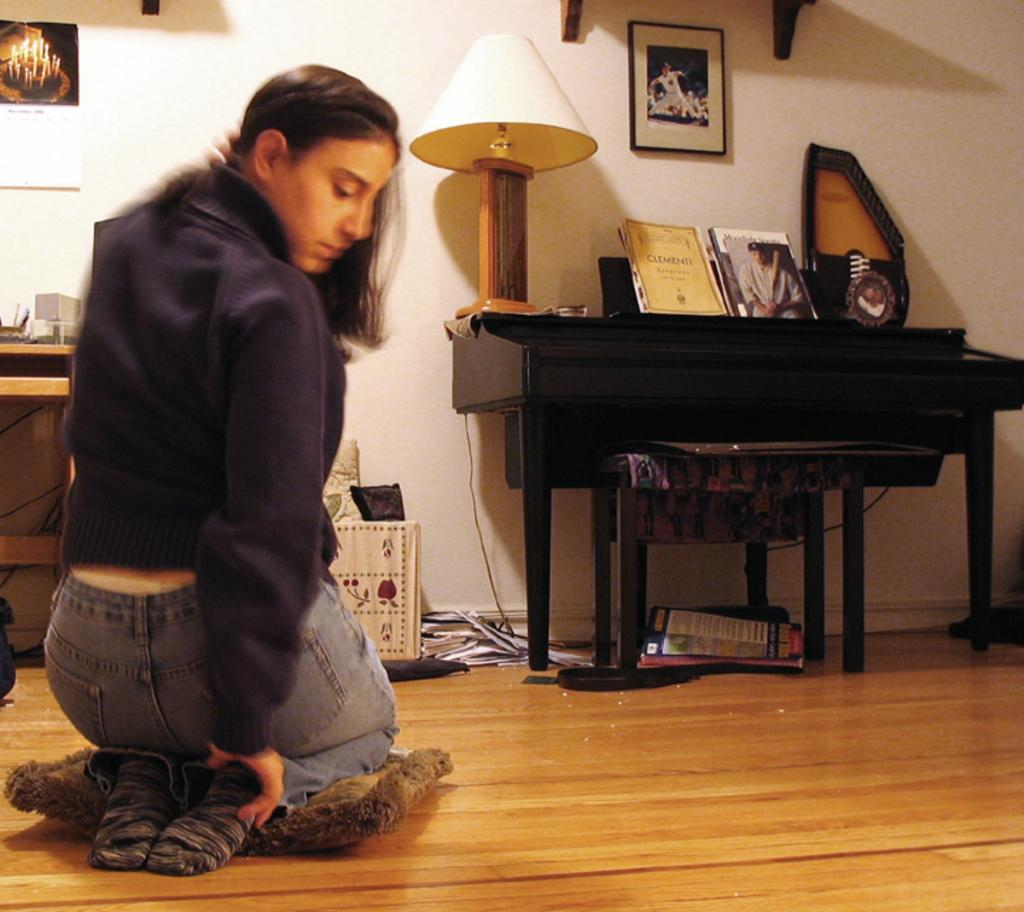What is the woman doing in the image? The woman is seated on the floor in the image. What can be seen in the image that provides light? There is a light in the image. What items are on the table in the image? There are books and shields on the table in the image. What decorations are on the wall in the image? There are wall posters on the wall in the image. What is the woman experiencing while smashing the brake in the image? There is no indication in the image that the woman is experiencing anything or smashing a brake; she is simply seated on the floor. 